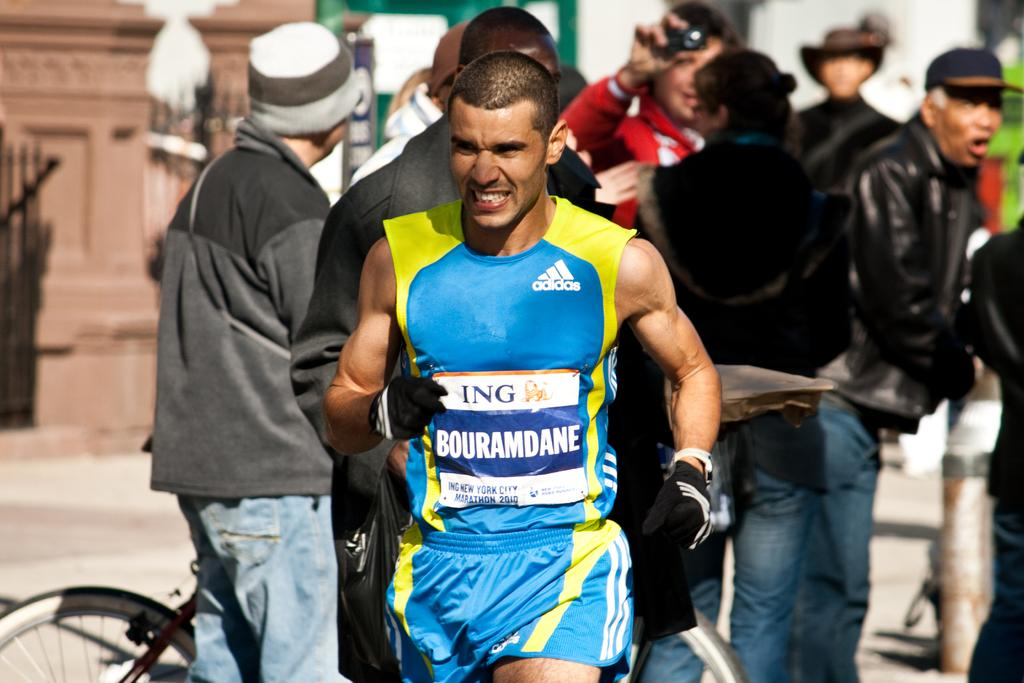<image>
Write a terse but informative summary of the picture. A man running in an Adidas athletic tank top. 